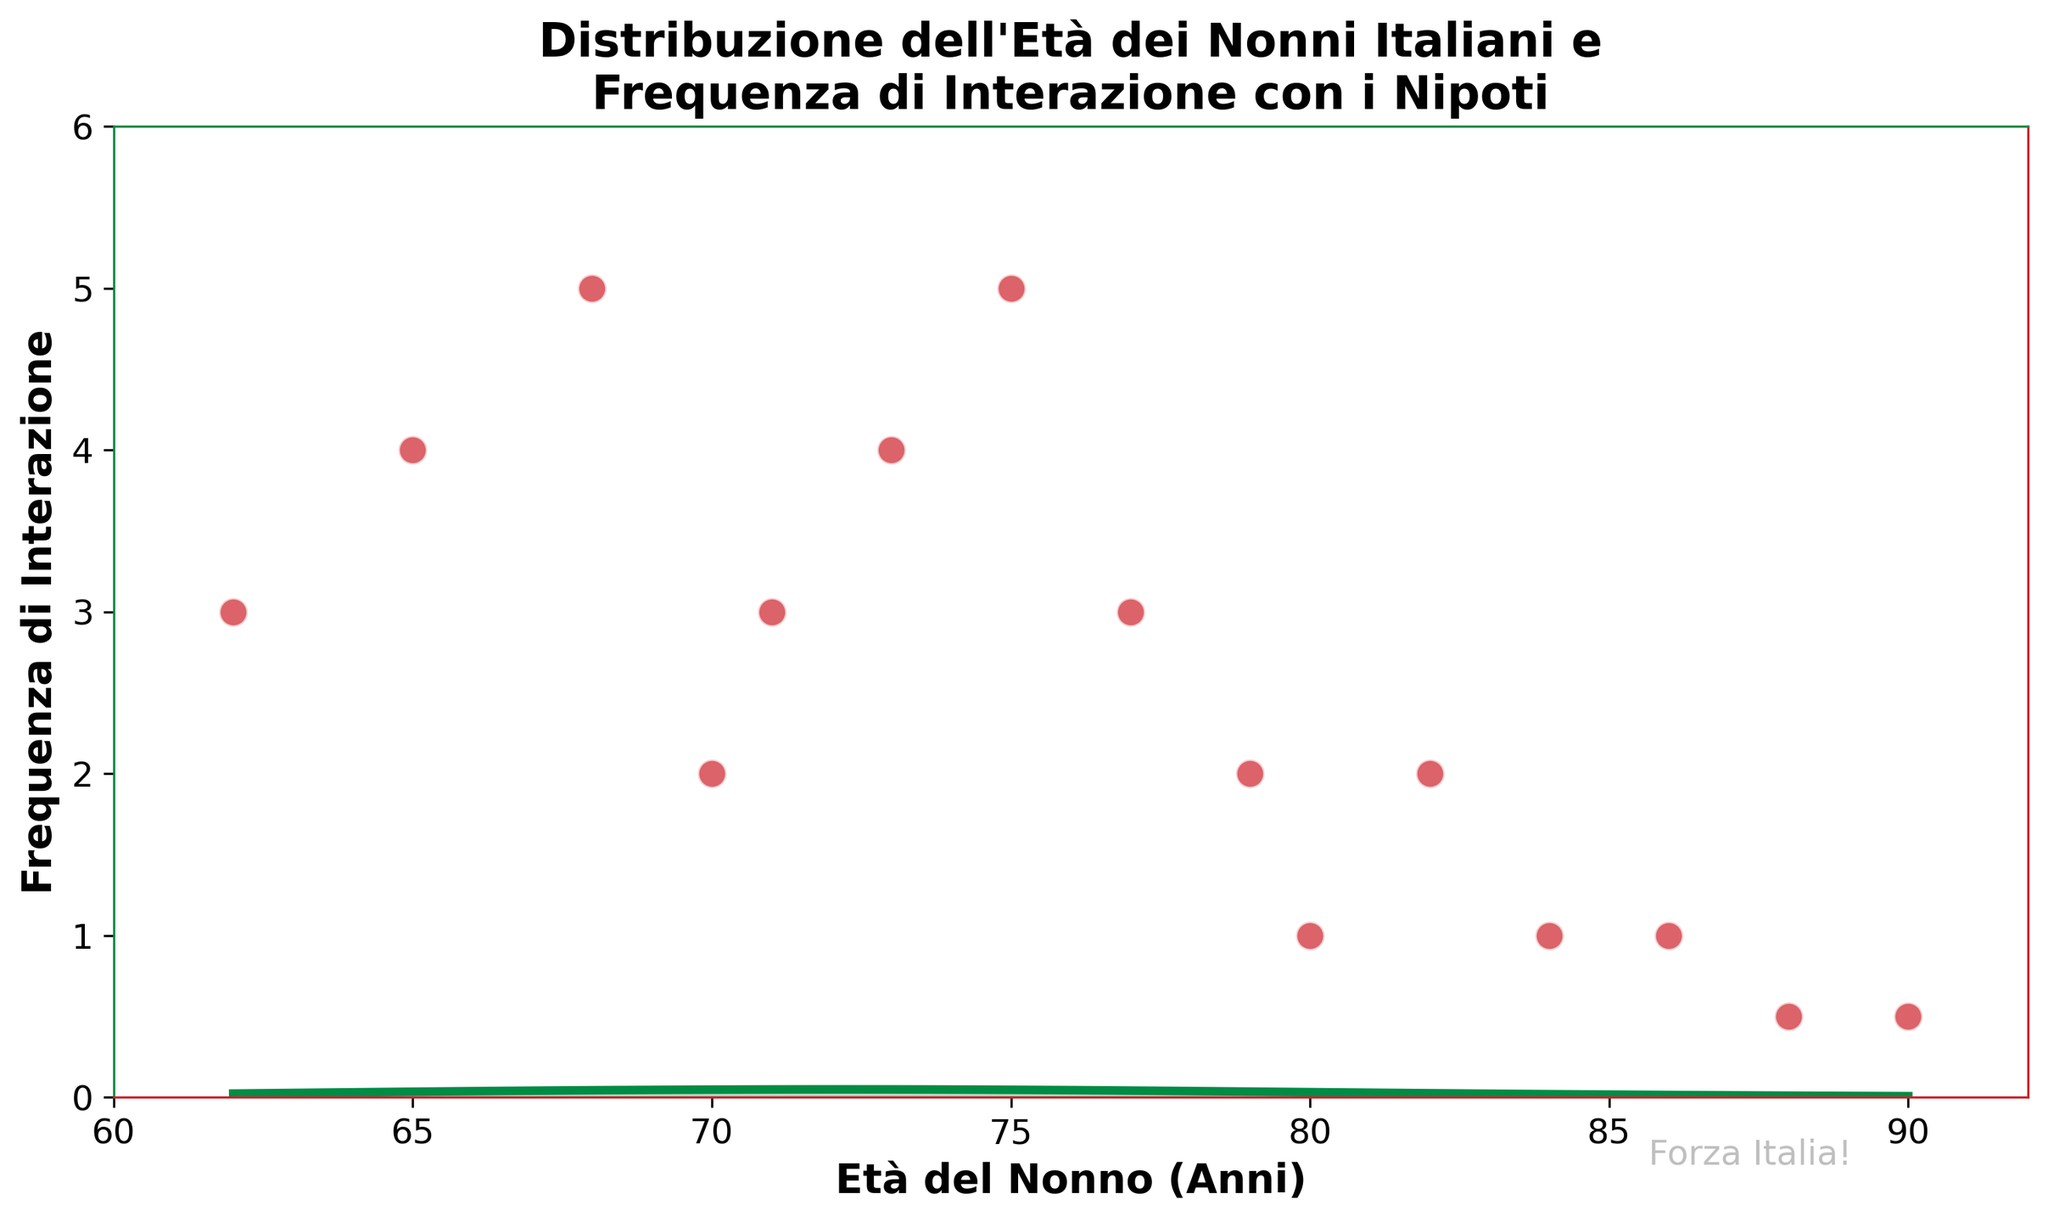What's the title of the plot? Looking at the top of the plot, the title displayed provides a clear description of what the plot represents.
Answer: Distribuzione dell'Età dei Nonni Italiani e Frequenza di Interazione con i Nipoti What do the x-axis and y-axis represent? The x-axis and y-axis labels describe the measured variables. The x-axis is labeled "Età del Nonno (Anni)" and the y-axis is labeled "Frequenza di Interazione".
Answer: Età del Nonno (Anni) and Frequenza di Interazione How many data points are there in the scatter plot? By counting each of the individual points plotted on the scatter part of the plot, we can determine the total number of data points.
Answer: 15 Which age group has the highest interaction frequency with grandchildren? Observing the y-axis value for each age group plotted in the scatter plot, it is clear which age group has the highest frequency of interaction.
Answer: 68 and 75 years old What is the interaction frequency for a 79-year-old grandfather? By locating the scatter plot point that corresponds to 79 years old on the x-axis, we can read the y-axis value for its interaction frequency.
Answer: 2 At which age does the interaction frequency start to significantly decrease? By observing the trend in the scatter plot, we can determine the age at which the interaction frequency notably drops.
Answer: Around 84 years old Which age group has the lowest frequency of interaction? By examining the y-axis values for each age group plotted in the scatter plot, we can identify the age group with the lowest frequency of interaction.
Answer: 88 and 90 years old Does the density curve suggest that interaction frequency peaks at a certain age range? By examining the shape and peak of the density curve plotted, we can determine if there is a peak in interaction frequency around certain age values.
Answer: Yes, around 68 and 75 years old Is there any age group that shows a steady trend in interaction frequency? By analyzing the scatter plot points and their corresponding y-values, we can identify if any ages have similar interaction frequencies.
Answer: Yes, ages 62, 71, 77, and 79 have similar interaction frequencies What color is used to fill the density plot? The shaded area under the density curve indicates the fill color, which is used consistently in the plot for the density representation.
Answer: Green 